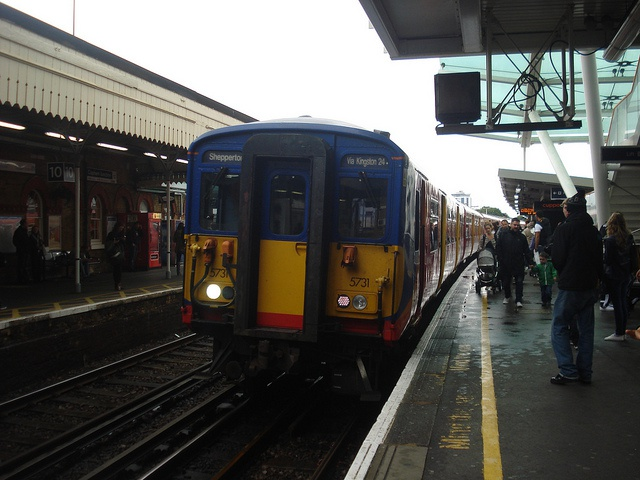Describe the objects in this image and their specific colors. I can see train in white, black, navy, maroon, and olive tones, people in white, black, darkblue, gray, and purple tones, people in white, black, and gray tones, people in white, black, and gray tones, and people in white, black, and gray tones in this image. 